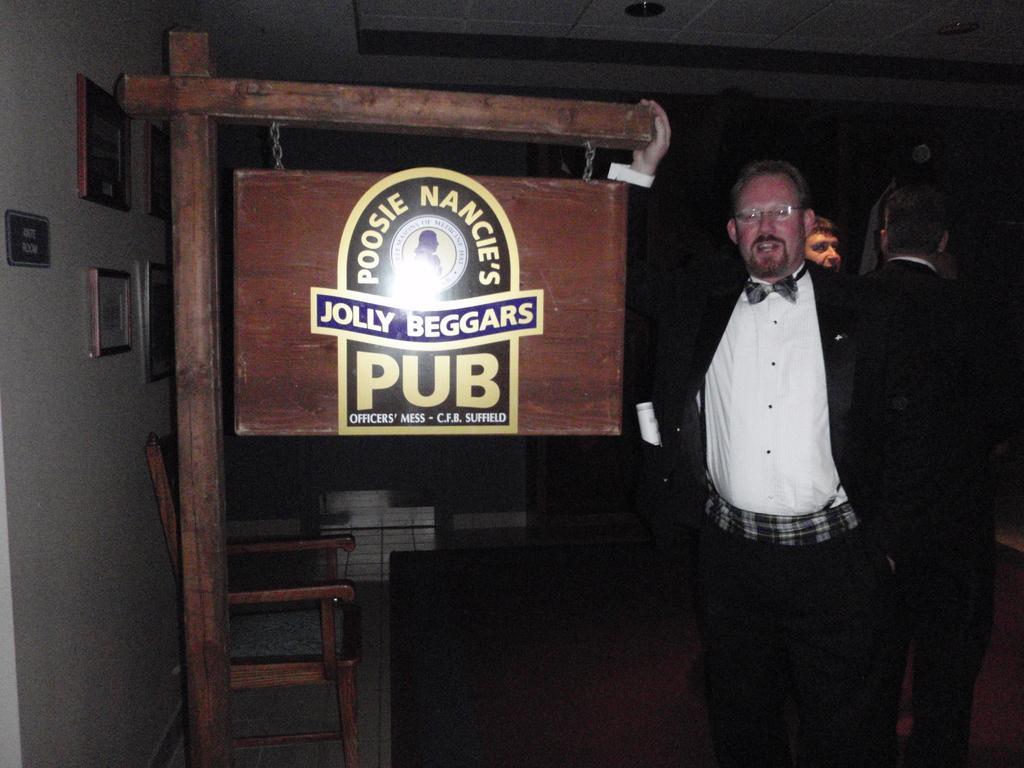Could you give a brief overview of what you see in this image? In this image, In the right side there are some people standing and one person is holding a wooden block, In the left side there is a wooden block of brown color on that jolly beggar is written, in the left side there is a white color wall. 